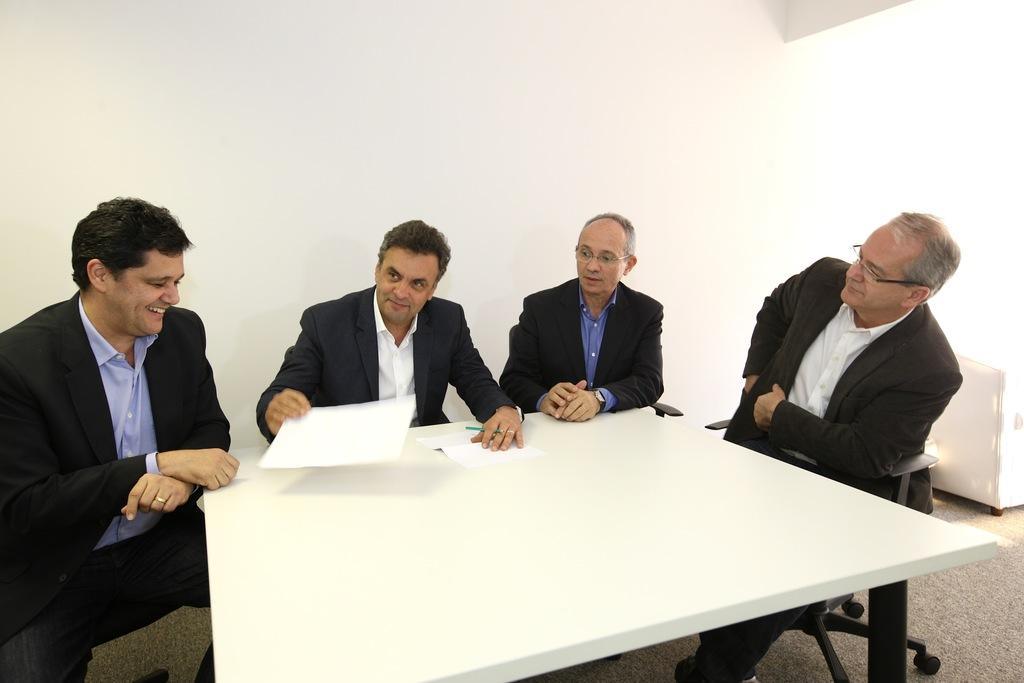What is the main subject of the image? The main subject of the image is a group of men. What are the men doing in the image? The men are sitting on chairs in the image. What can be seen behind the men? There is a white color table behind the men. What type of structure is being operated by the men in the image? There is no structure or operation depicted in the image; it simply shows a group of men sitting on chairs in front of a white color table. 